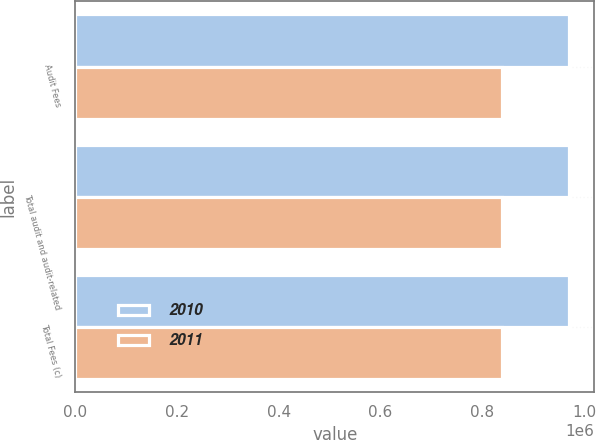Convert chart. <chart><loc_0><loc_0><loc_500><loc_500><stacked_bar_chart><ecel><fcel>Audit Fees<fcel>Total audit and audit-related<fcel>Total Fees (c)<nl><fcel>2010<fcel>971218<fcel>971218<fcel>971218<nl><fcel>2011<fcel>838092<fcel>838092<fcel>838092<nl></chart> 